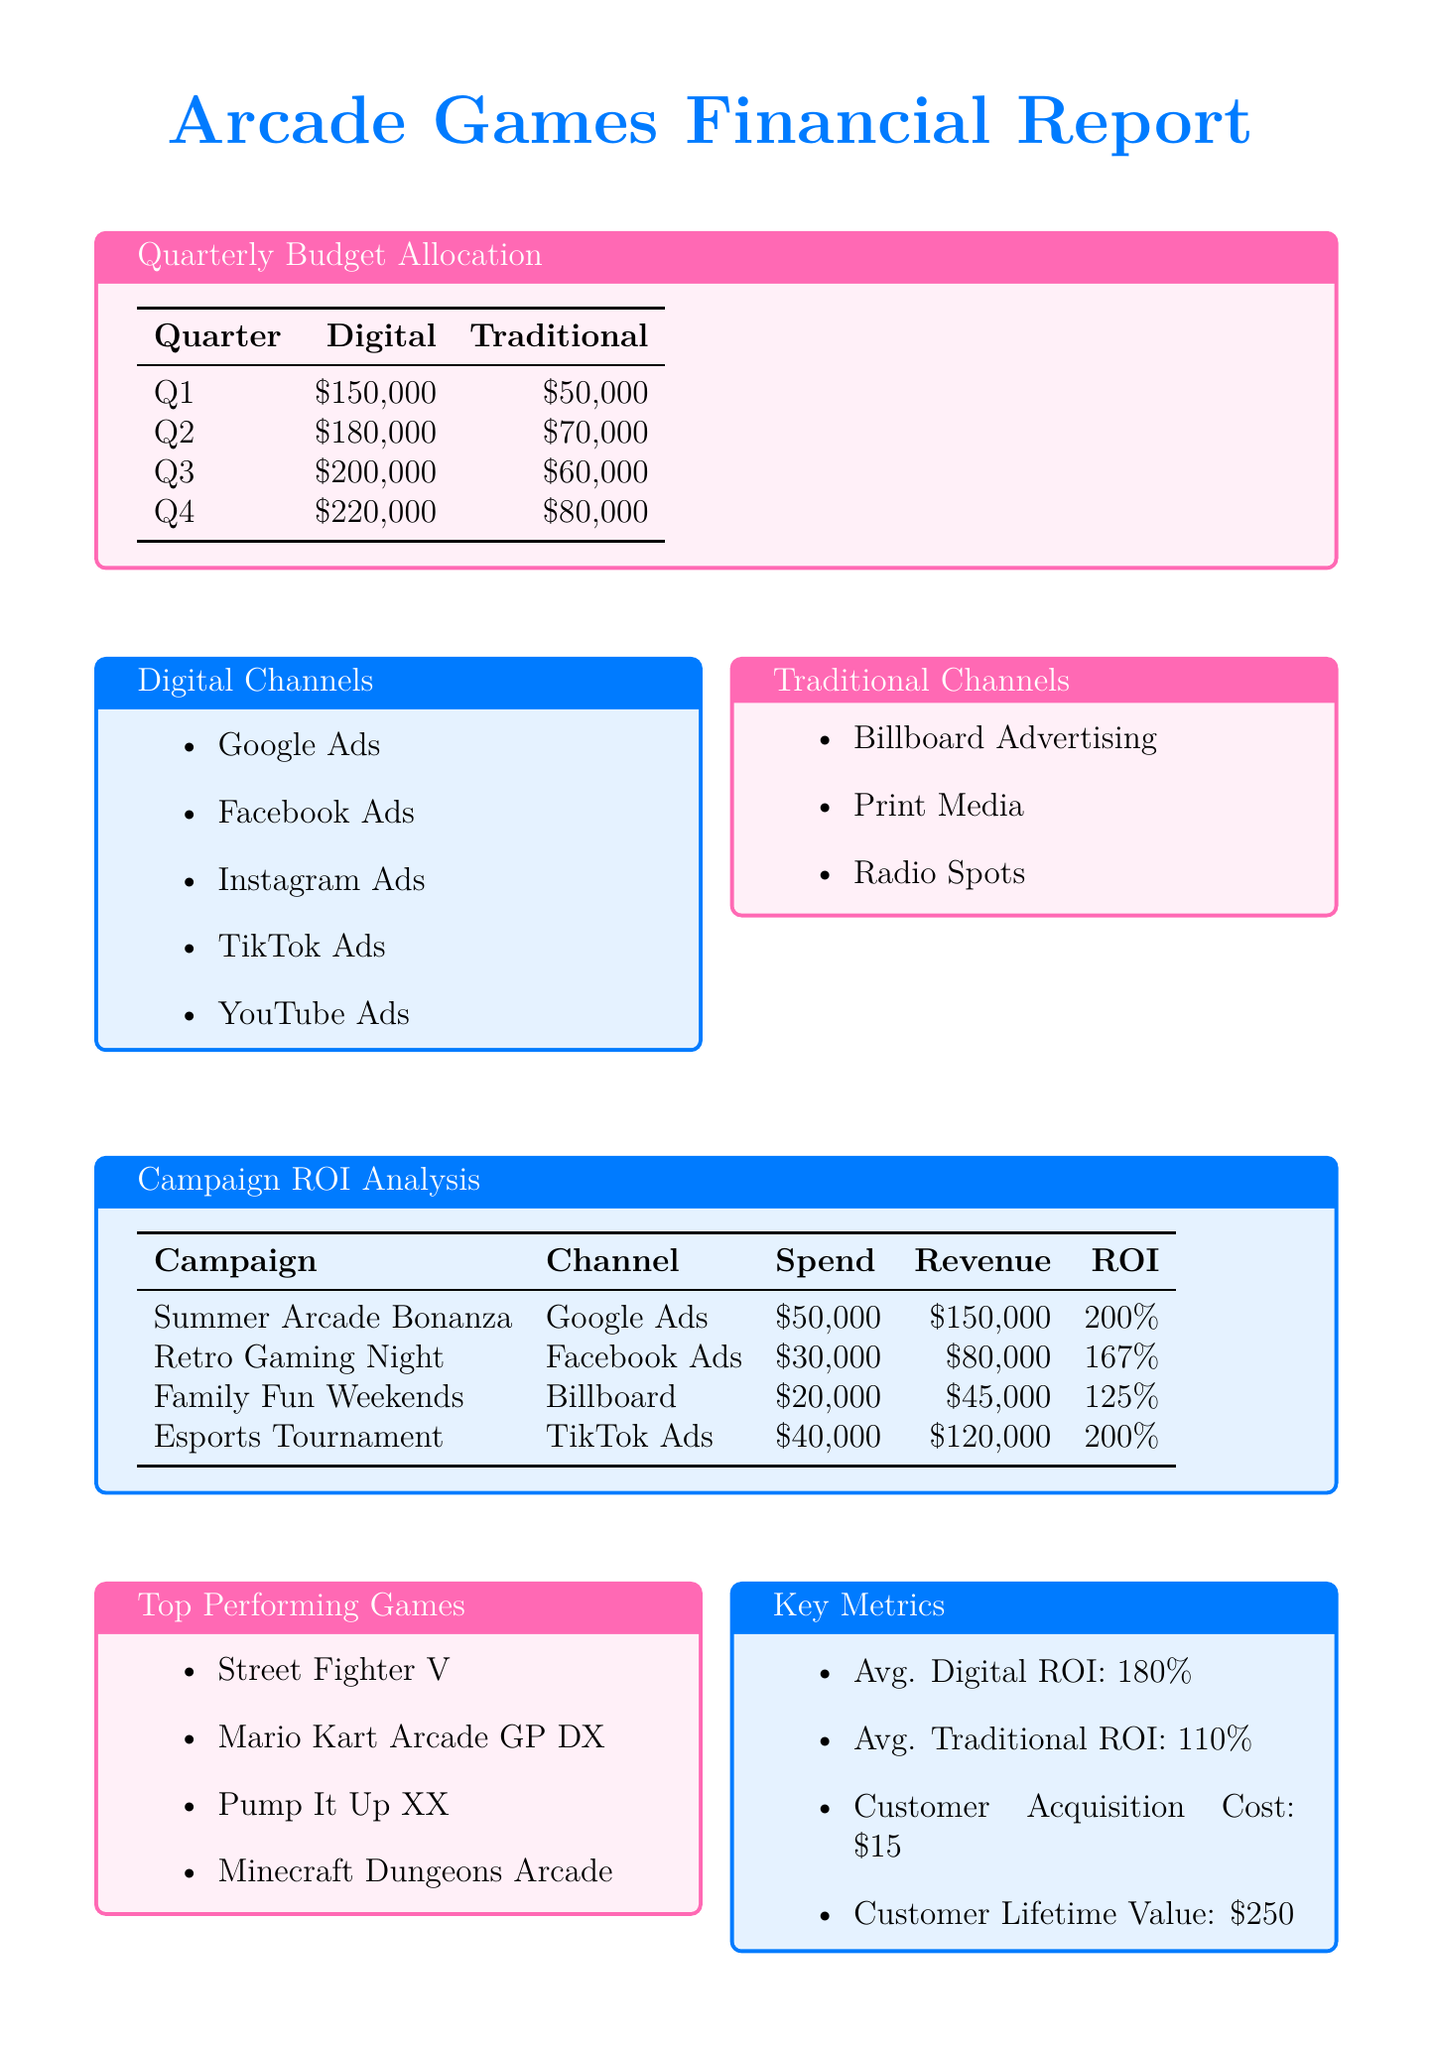What was the budget allocated for digital marketing in Q3? The budget allocated for digital marketing in Q3 is specified in the quarterly budget allocation table.
Answer: 200000 Which campaign had the highest ROI, and what was the percentage? The campaign with the highest ROI is identified in the campaign ROI analysis section, which lists the ROIs for different campaigns.
Answer: 200% What is the total traditional marketing budget for the entire year? The total traditional marketing budget is the sum of the traditional budgets for all four quarters as shown in the quarterly budget allocation.
Answer: 240000 What is the average digital ROI across all campaigns? The average digital ROI is indicated in the key metrics section of the document, summarizing performance from all digital campaigns analyzed.
Answer: 180% Which digital channel is included in the budget allocation? The digital channels are listed in the separate section regarding digital channels, which identifies all channels employed for marketing.
Answer: Google Ads What was the spending for the Family Fun Weekends campaign? The spending for the Family Fun Weekends campaign is found in the campaign ROI analysis table detailing each campaign's financials.
Answer: 20000 What was the customer acquisition cost mentioned in the key metrics? The customer acquisition cost is specifically highlighted in the key metrics section providing all relevant financial metrics.
Answer: 15 What is the total revenue generated by the Esports Tournament campaign? The total revenue for the Esports Tournament campaign is listed in the campaign ROI analysis, revealing the revenue generated from that specific effort.
Answer: 120000 